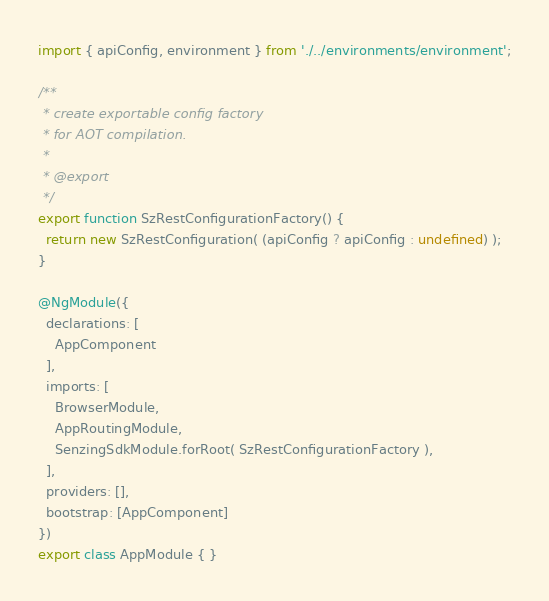<code> <loc_0><loc_0><loc_500><loc_500><_TypeScript_>import { apiConfig, environment } from './../environments/environment';

/**
 * create exportable config factory
 * for AOT compilation.
 *
 * @export
 */
export function SzRestConfigurationFactory() {
  return new SzRestConfiguration( (apiConfig ? apiConfig : undefined) );
}

@NgModule({
  declarations: [
    AppComponent
  ],
  imports: [
    BrowserModule,
    AppRoutingModule,
    SenzingSdkModule.forRoot( SzRestConfigurationFactory ),
  ],
  providers: [],
  bootstrap: [AppComponent]
})
export class AppModule { }
</code> 